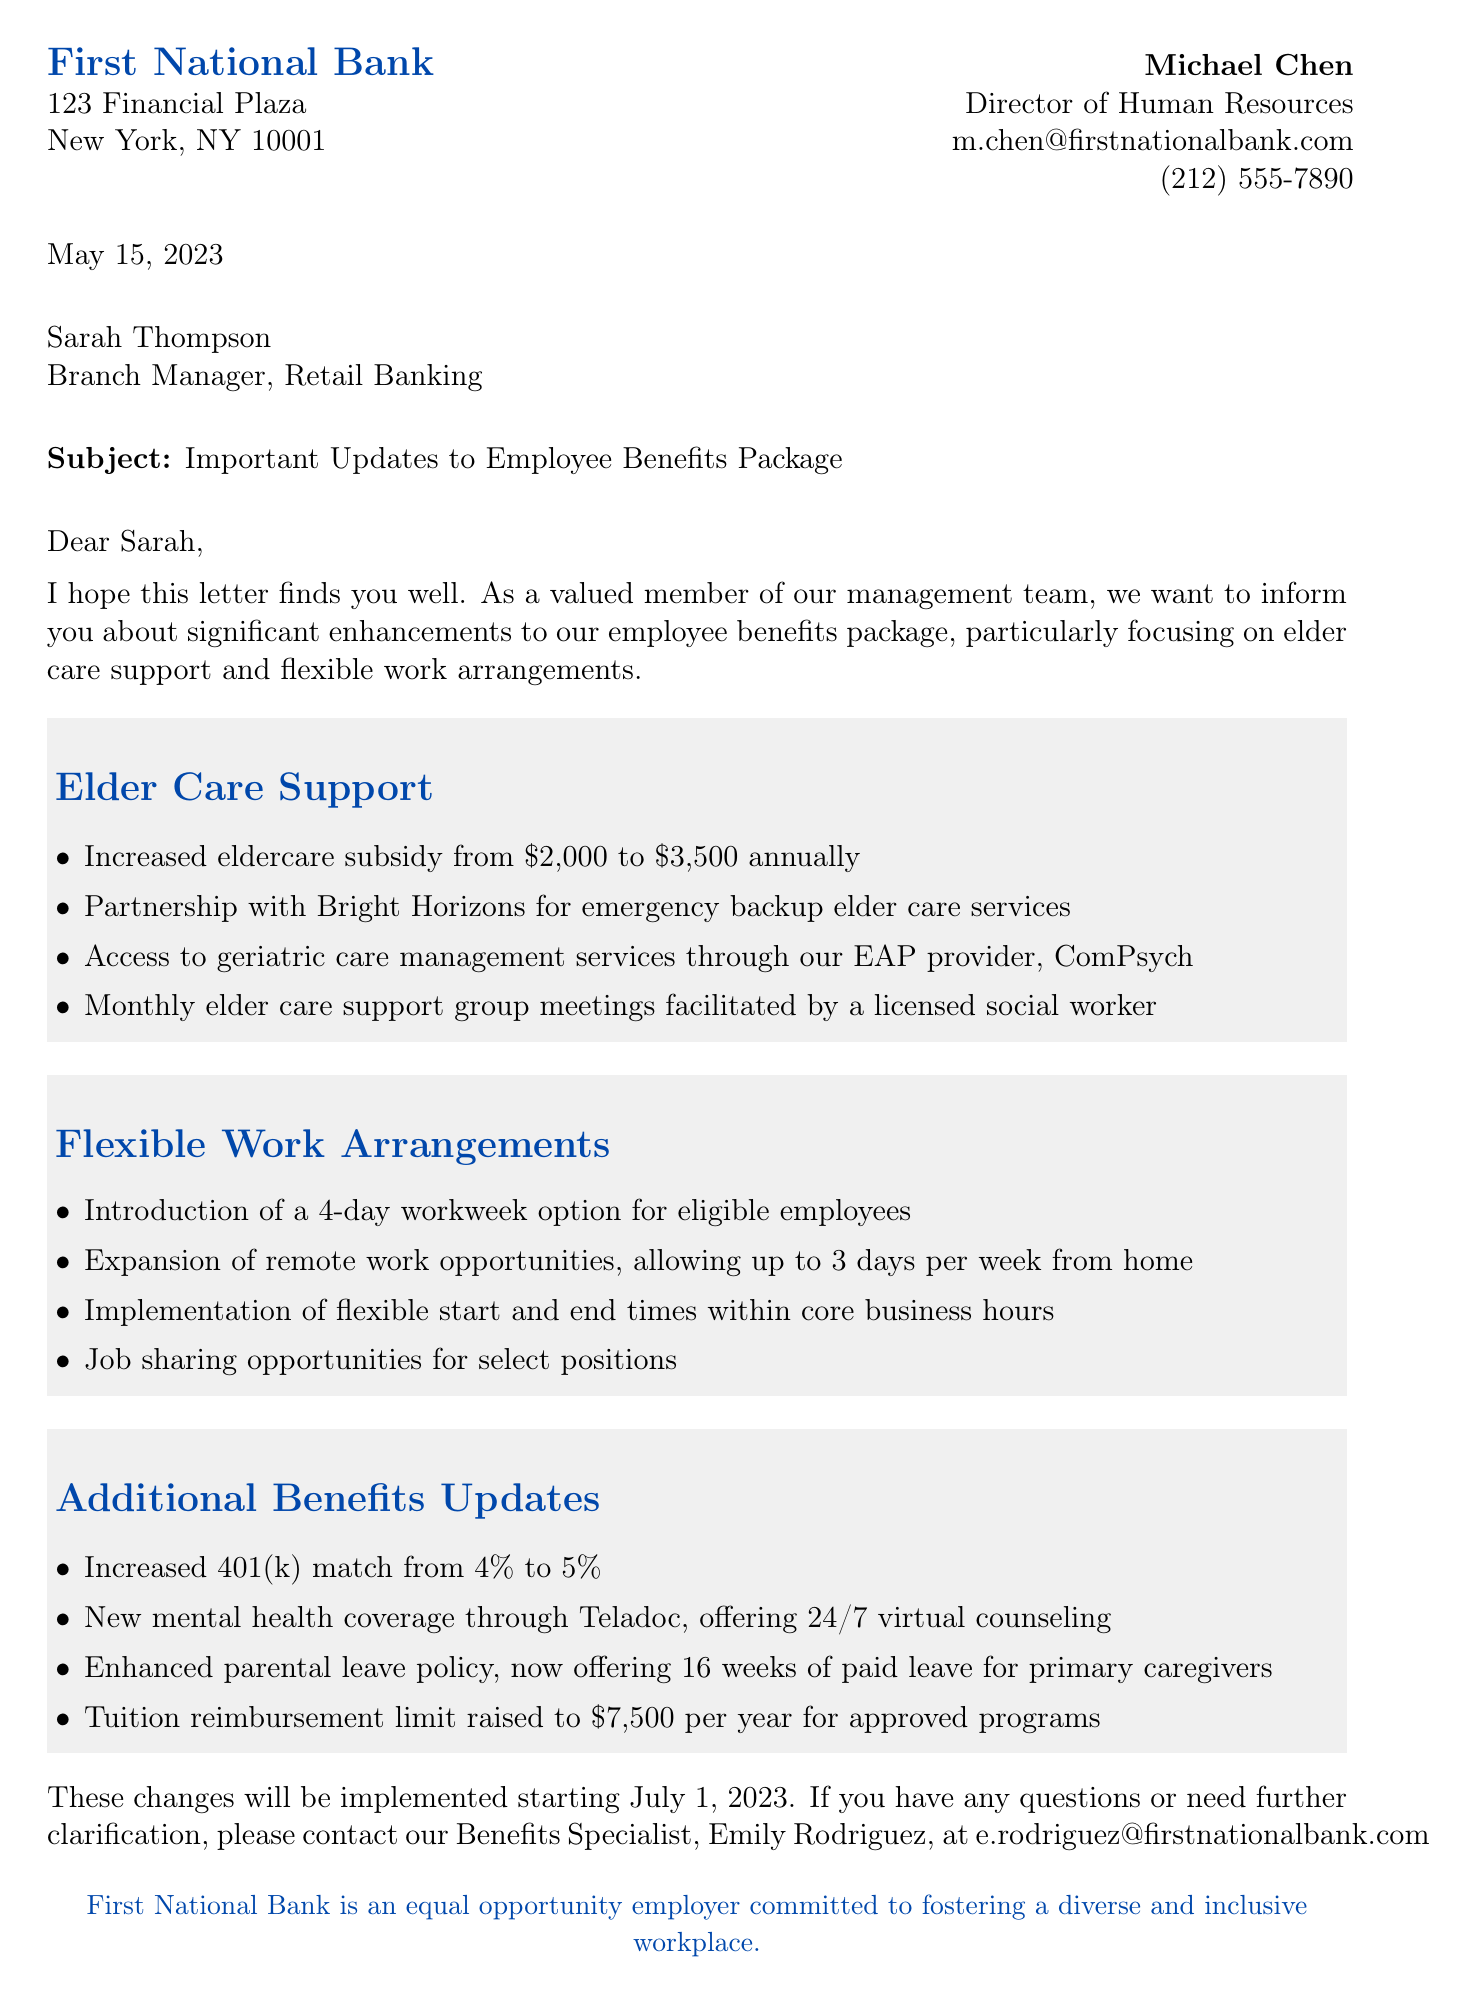What is the name of the bank? The name of the bank is mentioned at the beginning of the letter.
Answer: First National Bank Who is the sender of the letter? The letter specifies the sender's name and title.
Answer: Michael Chen What is the increased eldercare subsidy amount? The document states the new annual eldercare subsidy amount clearly.
Answer: $3,500 When will the changes be implemented? The document mentions the date when the new benefits will take effect.
Answer: July 1, 2023 What is one of the new flexible work options? The letter lists various flexible work arrangements being introduced.
Answer: 4-day workweek option What is the email address of the Benefits Specialist? The contact information for the Benefits Specialist is provided in the letter.
Answer: e.rodriguez@firstnationalbank.com What percentage did the 401(k) match increase to? The document provides specific details about the 401(k) match update.
Answer: 5% How does the bank support elder care? The letter outlines several benefits related to elder care support.
Answer: Increased eldercare subsidy What type of letter is this? The document's structure and content indicate the type of correspondence.
Answer: Formal letter 